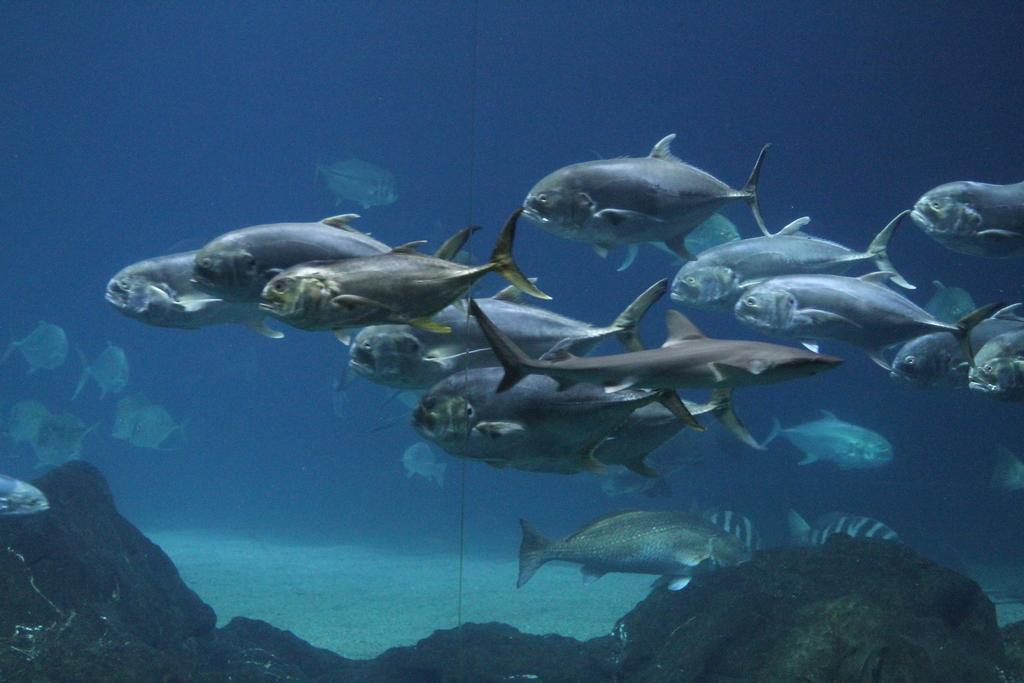Describe this image in one or two sentences. In this picture we can see the fishes and the rocks. It also looks like an aquarium. 